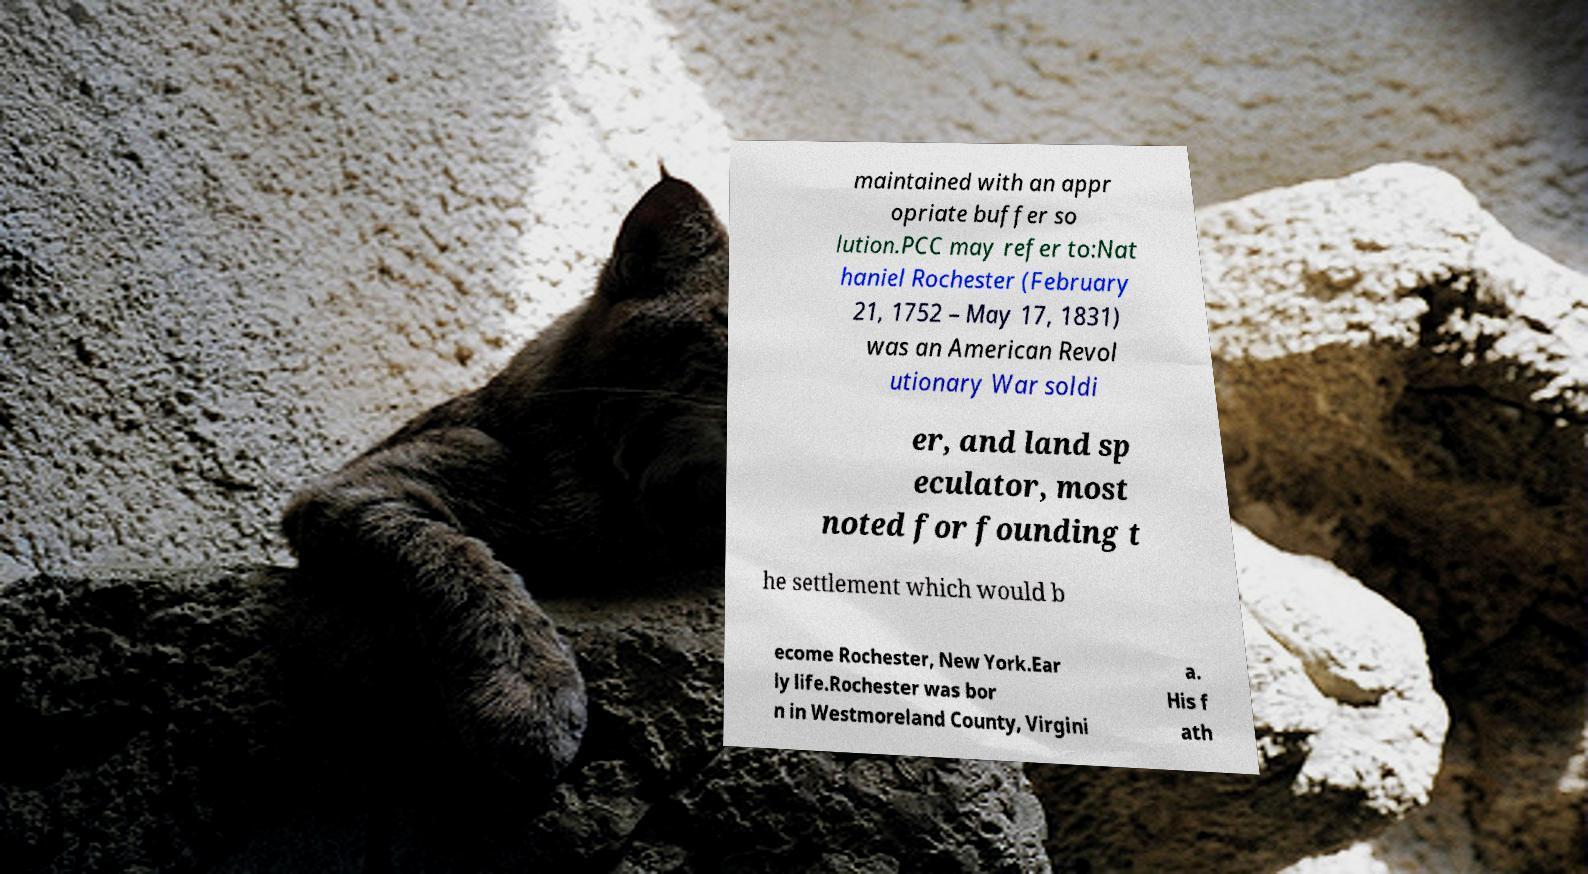I need the written content from this picture converted into text. Can you do that? maintained with an appr opriate buffer so lution.PCC may refer to:Nat haniel Rochester (February 21, 1752 – May 17, 1831) was an American Revol utionary War soldi er, and land sp eculator, most noted for founding t he settlement which would b ecome Rochester, New York.Ear ly life.Rochester was bor n in Westmoreland County, Virgini a. His f ath 